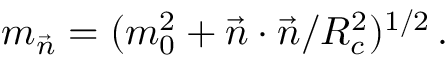<formula> <loc_0><loc_0><loc_500><loc_500>m _ { \vec { n } } = ( m _ { 0 } ^ { 2 } + \vec { n } \cdot \vec { n } / R _ { c } ^ { 2 } ) ^ { 1 / 2 } \, .</formula> 